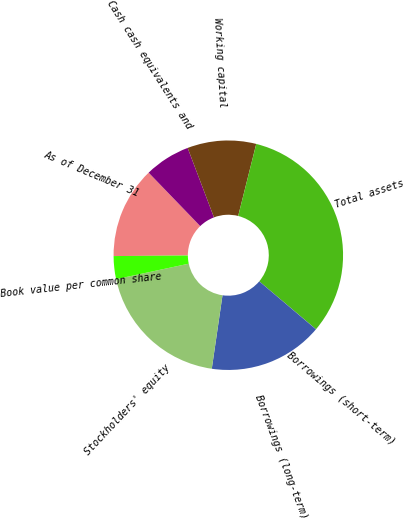Convert chart. <chart><loc_0><loc_0><loc_500><loc_500><pie_chart><fcel>As of December 31<fcel>Cash cash equivalents and<fcel>Working capital<fcel>Total assets<fcel>Borrowings (short-term)<fcel>Borrowings (long-term)<fcel>Stockholders' equity<fcel>Book value per common share<nl><fcel>12.9%<fcel>6.45%<fcel>9.68%<fcel>32.25%<fcel>0.01%<fcel>16.13%<fcel>19.35%<fcel>3.23%<nl></chart> 